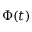Convert formula to latex. <formula><loc_0><loc_0><loc_500><loc_500>\Phi ( t )</formula> 